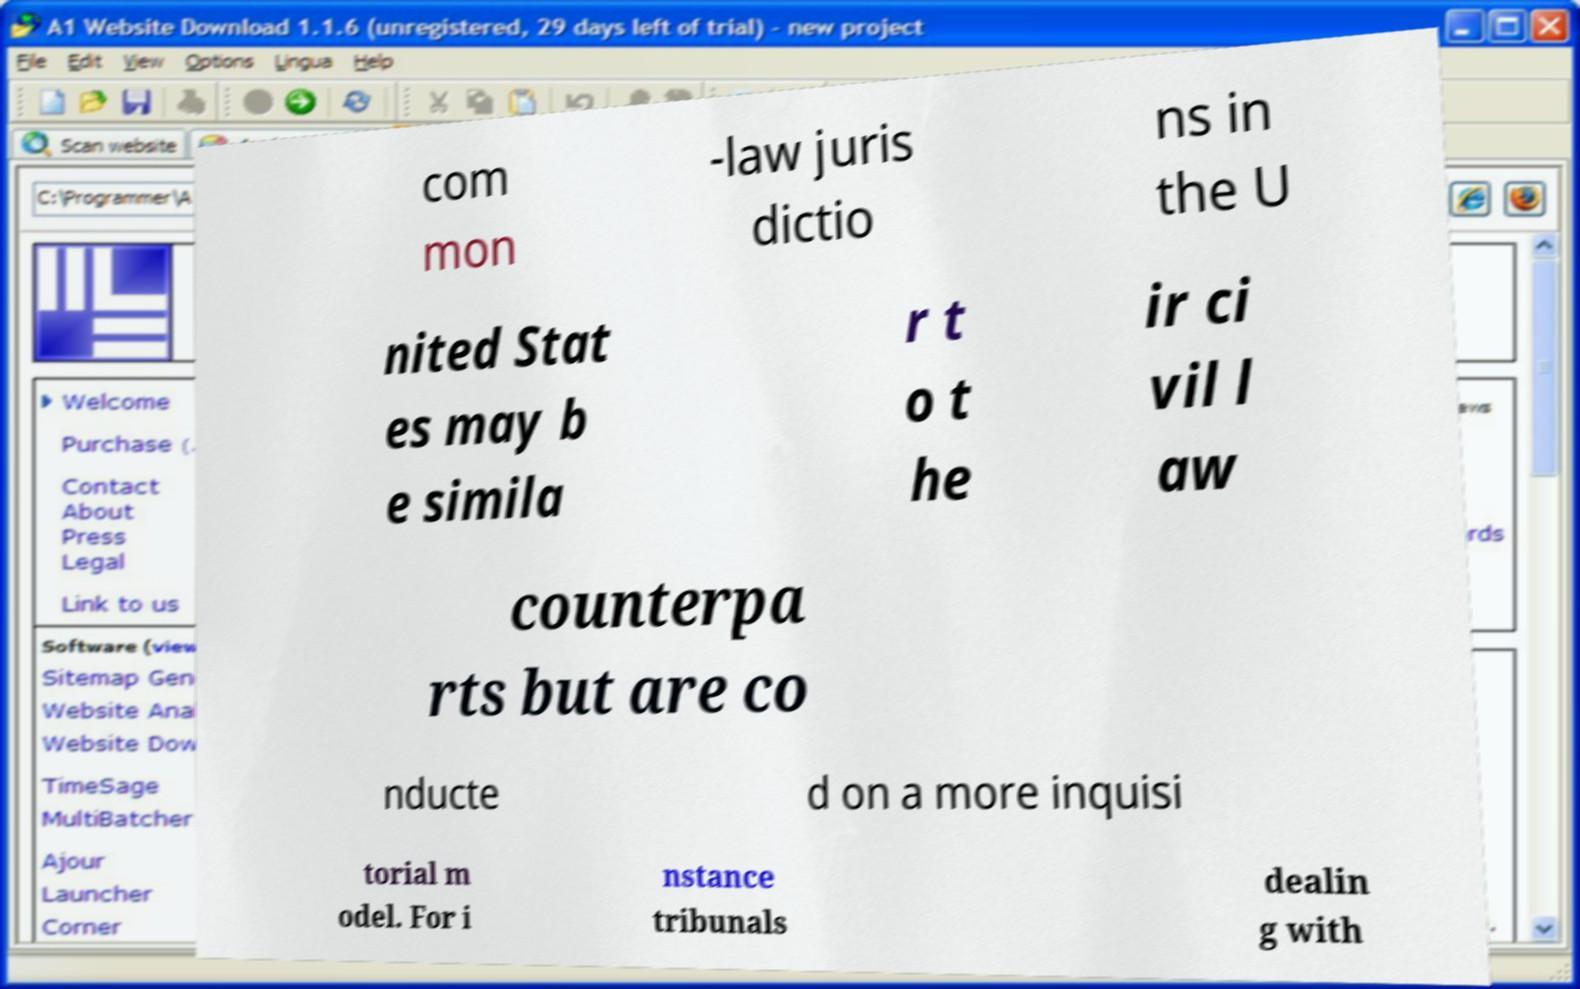Please read and relay the text visible in this image. What does it say? com mon -law juris dictio ns in the U nited Stat es may b e simila r t o t he ir ci vil l aw counterpa rts but are co nducte d on a more inquisi torial m odel. For i nstance tribunals dealin g with 